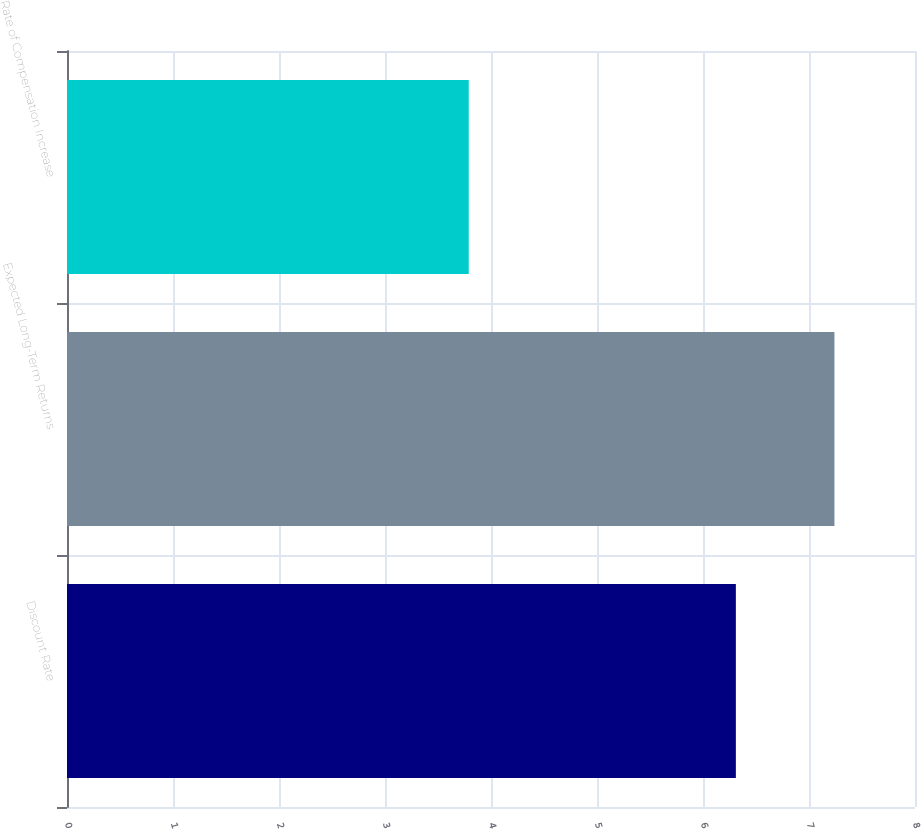Convert chart. <chart><loc_0><loc_0><loc_500><loc_500><bar_chart><fcel>Discount Rate<fcel>Expected Long-Term Returns<fcel>Rate of Compensation Increase<nl><fcel>6.31<fcel>7.24<fcel>3.79<nl></chart> 